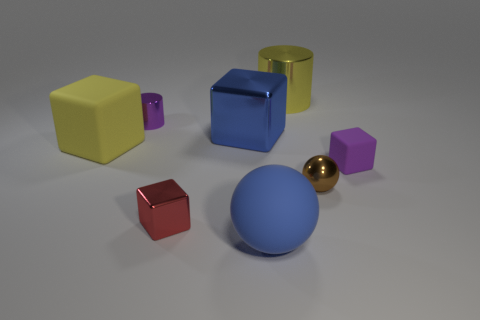There is a sphere in front of the tiny red metal thing; does it have the same size as the matte block left of the purple matte thing?
Give a very brief answer. Yes. What number of balls are big yellow metallic objects or yellow objects?
Your answer should be very brief. 0. Are the large yellow object behind the yellow block and the small brown thing made of the same material?
Keep it short and to the point. Yes. How many other things are the same size as the yellow cylinder?
Your answer should be very brief. 3. What number of small things are either red blocks or purple metal cylinders?
Provide a succinct answer. 2. Do the metallic sphere and the large matte sphere have the same color?
Ensure brevity in your answer.  No. Are there more small purple matte things in front of the blue matte object than large things behind the small metal cylinder?
Provide a short and direct response. No. Do the large metal thing to the right of the large blue ball and the small metal cylinder have the same color?
Keep it short and to the point. No. Are there any other things that have the same color as the large metallic block?
Your answer should be compact. Yes. Is the number of small red metallic cubes that are on the right side of the blue matte object greater than the number of brown metallic objects?
Provide a succinct answer. No. 